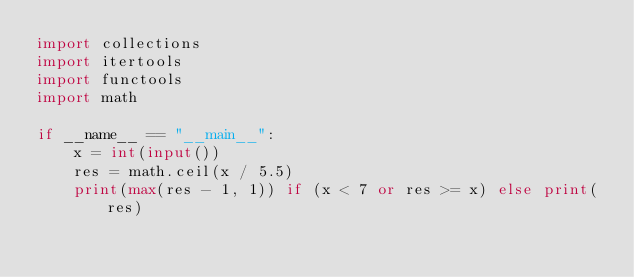Convert code to text. <code><loc_0><loc_0><loc_500><loc_500><_Python_>import collections
import itertools
import functools
import math

if __name__ == "__main__":
    x = int(input())
    res = math.ceil(x / 5.5)
    print(max(res - 1, 1)) if (x < 7 or res >= x) else print(res)
</code> 